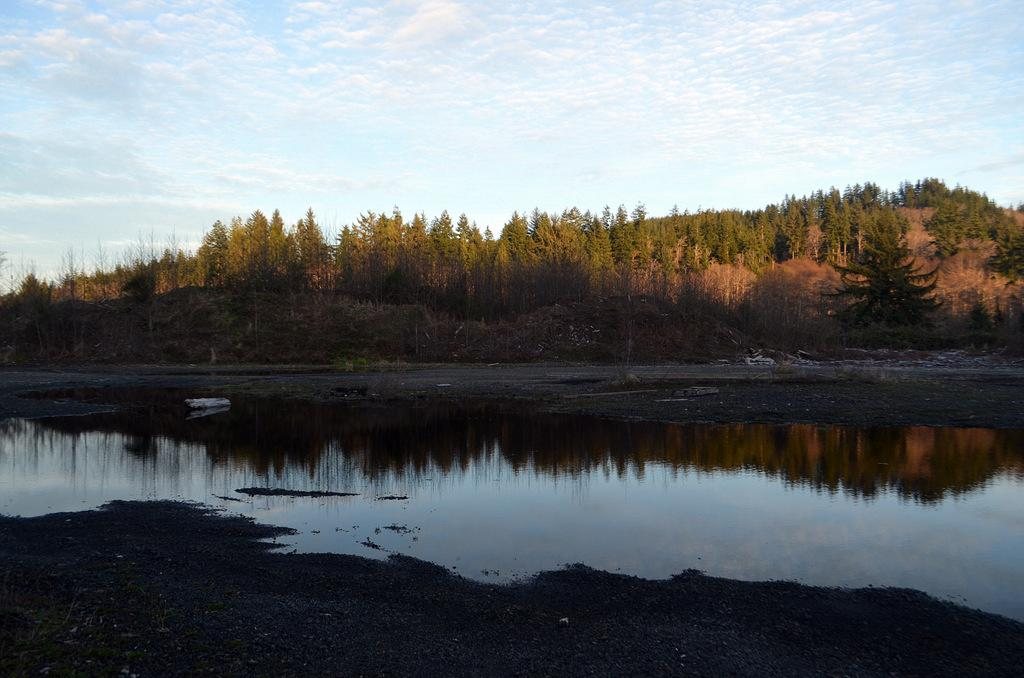What is in the foreground of the image? There is water in the foreground of the image. What can be seen in the background of the image? There are trees in the background of the image. What is visible in the sky in the image? Clouds are visible in the sky. What is the point of the argument being made by the trees in the image? There is no argument being made by the trees in the image, as trees do not have the ability to make arguments. Is there a plough visible in the image? There is no plough present in the image. 